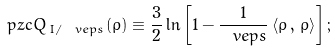<formula> <loc_0><loc_0><loc_500><loc_500>\ p z c Q _ { \, I / \ v e p s } ( \rho ) \equiv \frac { 3 } { 2 } \ln \left [ 1 - { \frac { 1 } { \ v e p s } } \left \langle \rho \, , \, \rho \right \rangle \right ] ;</formula> 